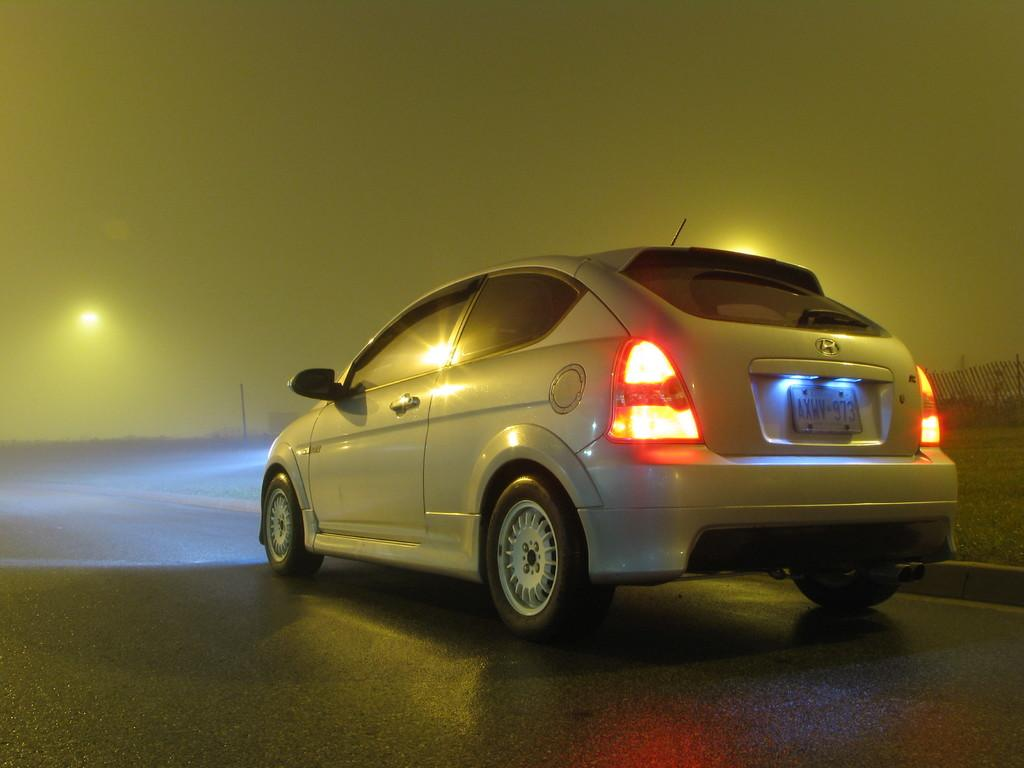<image>
Summarize the visual content of the image. A car on the road has AXWY on the license plate. 